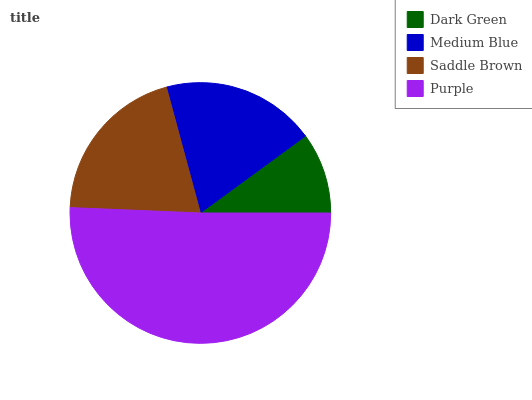Is Dark Green the minimum?
Answer yes or no. Yes. Is Purple the maximum?
Answer yes or no. Yes. Is Medium Blue the minimum?
Answer yes or no. No. Is Medium Blue the maximum?
Answer yes or no. No. Is Medium Blue greater than Dark Green?
Answer yes or no. Yes. Is Dark Green less than Medium Blue?
Answer yes or no. Yes. Is Dark Green greater than Medium Blue?
Answer yes or no. No. Is Medium Blue less than Dark Green?
Answer yes or no. No. Is Saddle Brown the high median?
Answer yes or no. Yes. Is Medium Blue the low median?
Answer yes or no. Yes. Is Medium Blue the high median?
Answer yes or no. No. Is Saddle Brown the low median?
Answer yes or no. No. 